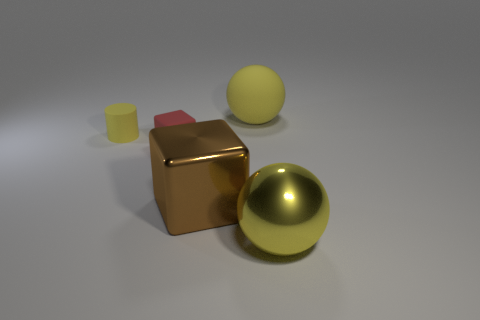Add 5 small blue metal cubes. How many objects exist? 10 Subtract all cylinders. How many objects are left? 4 Add 2 large red shiny spheres. How many large red shiny spheres exist? 2 Subtract 0 yellow cubes. How many objects are left? 5 Subtract all brown objects. Subtract all cylinders. How many objects are left? 3 Add 2 tiny red rubber blocks. How many tiny red rubber blocks are left? 3 